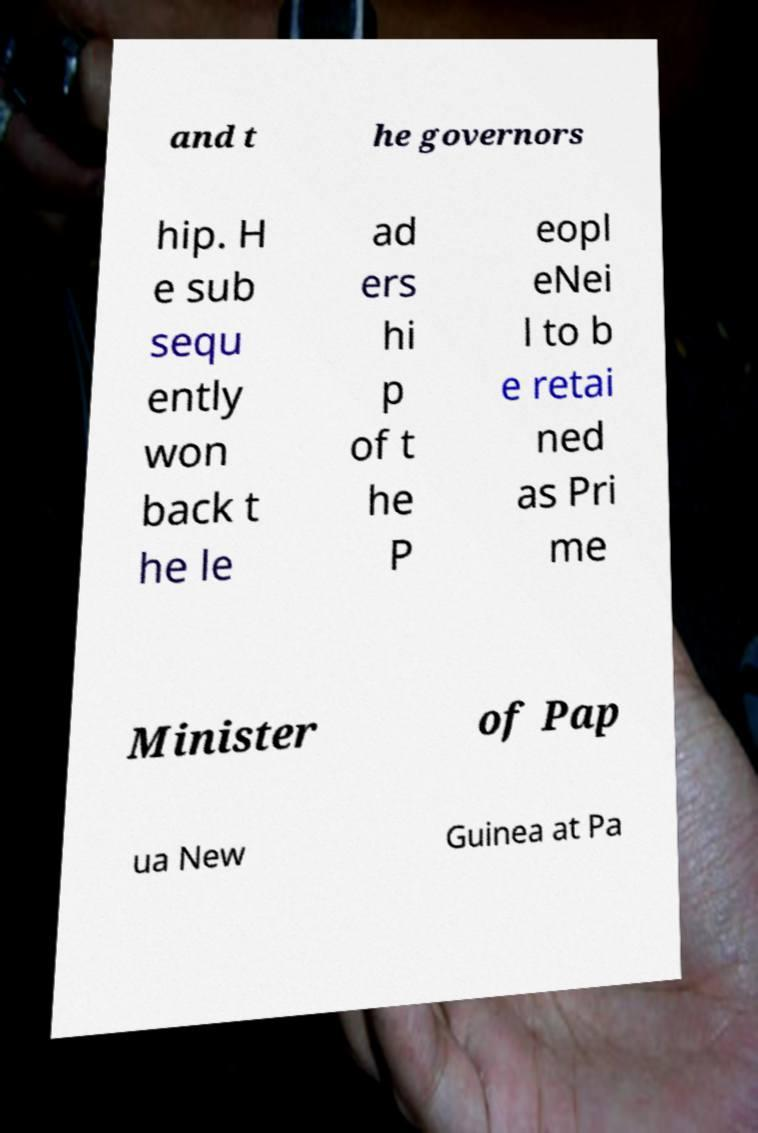I need the written content from this picture converted into text. Can you do that? and t he governors hip. H e sub sequ ently won back t he le ad ers hi p of t he P eopl eNei l to b e retai ned as Pri me Minister of Pap ua New Guinea at Pa 